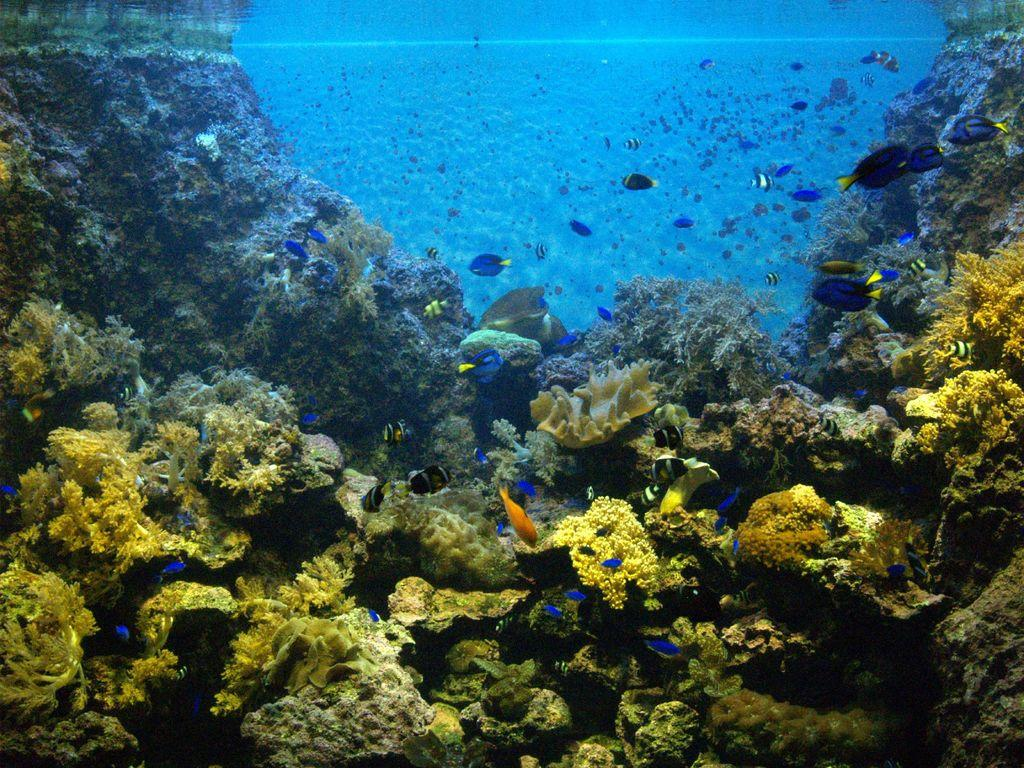What type of animals can be seen in the image? There are fish in the water. What can be found at the bottom of the image? There are plants on the rocks at the bottom of the image. What type of bell can be heard ringing in the image? There is no bell present in the image, so it is not possible to hear it ringing. 